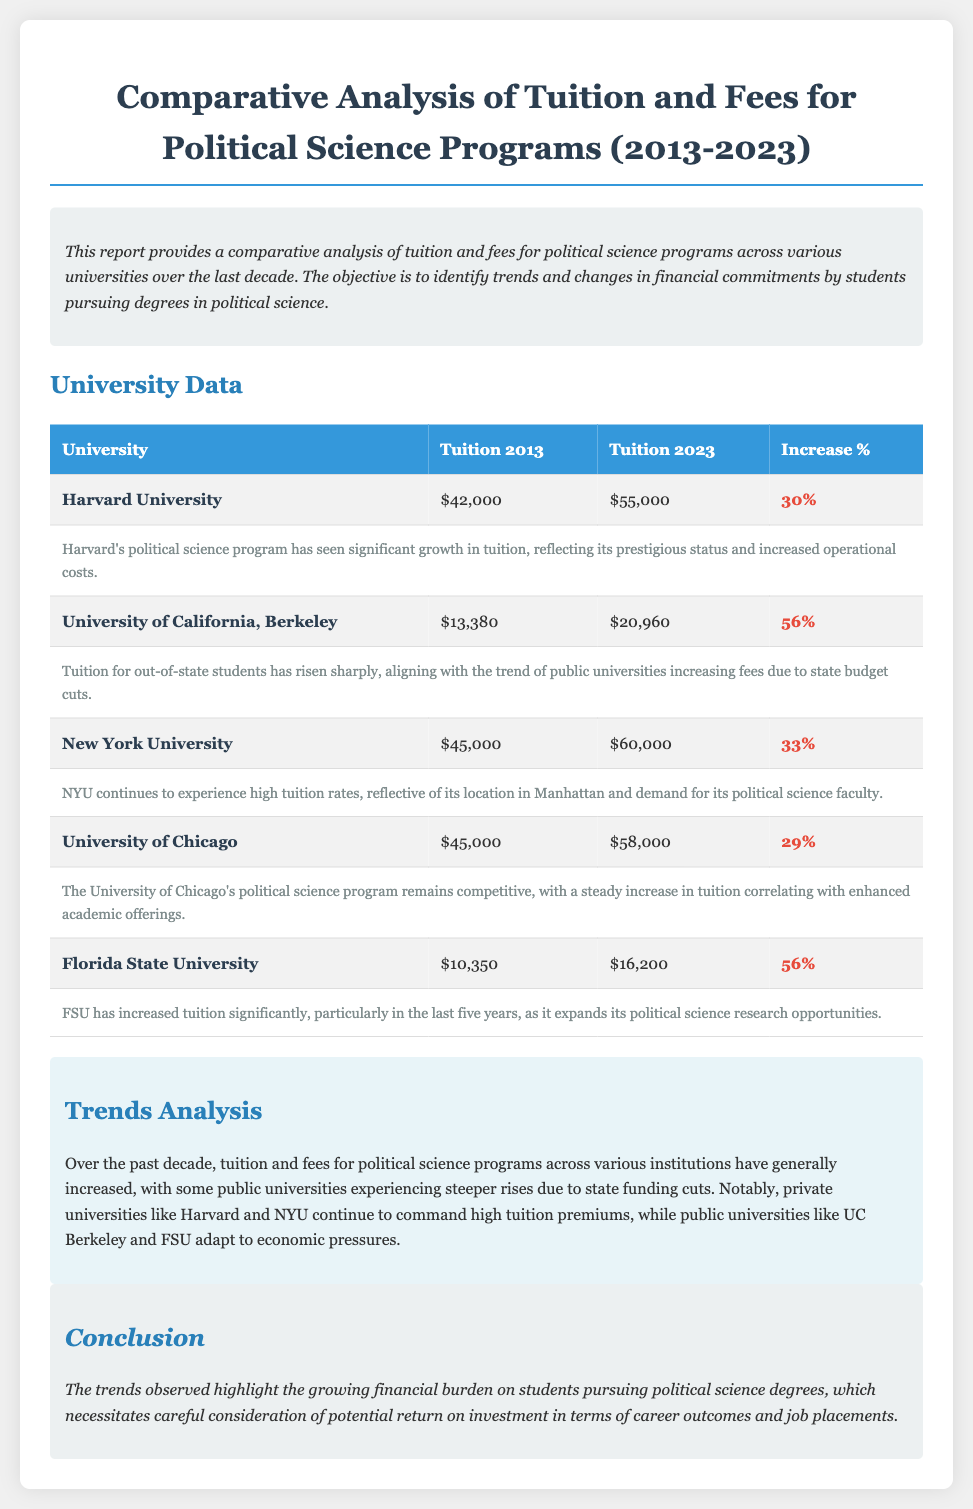What was Harvard University's tuition in 2013? The document states that Harvard University's tuition in 2013 was $42,000.
Answer: $42,000 What is the percentage increase in tuition for the University of California, Berkeley? The document indicates that UC Berkeley experienced a 56% increase in tuition from 2013 to 2023.
Answer: 56% Which university has the highest tuition in 2023? According to the document, the university with the highest tuition in 2023 is Harvard University with $55,000.
Answer: Harvard University What notable trend is observed in public universities' tuition? The document notes that public universities like UC Berkeley and FSU have steeper rises due to state funding cuts.
Answer: Steeper rises What is the total tuition cost in 2023 for Florida State University? The report lists Florida State University's tuition in 2023 as $16,200.
Answer: $16,200 What key conclusion does the report make about financial burdens? The conclusion drawn in the document is that the trends highlight a growing financial burden on students.
Answer: Growing financial burden What year does the analysis cover up to? The document states the analysis covers tuition data up to 2023.
Answer: 2023 What has influenced the high tuition rates at private universities? The document mentions that private universities like Harvard and NYU command high tuition premiums due to demand.
Answer: Demand 